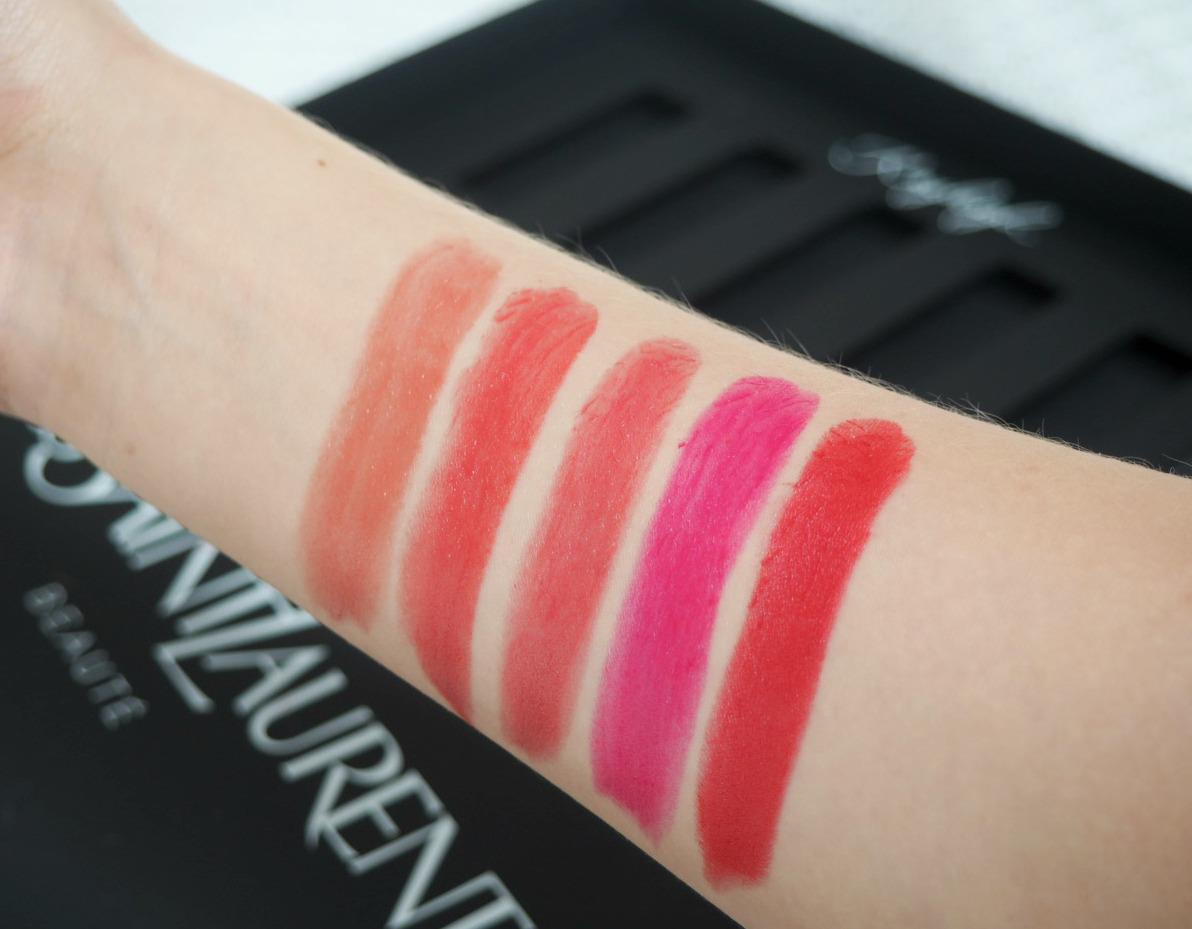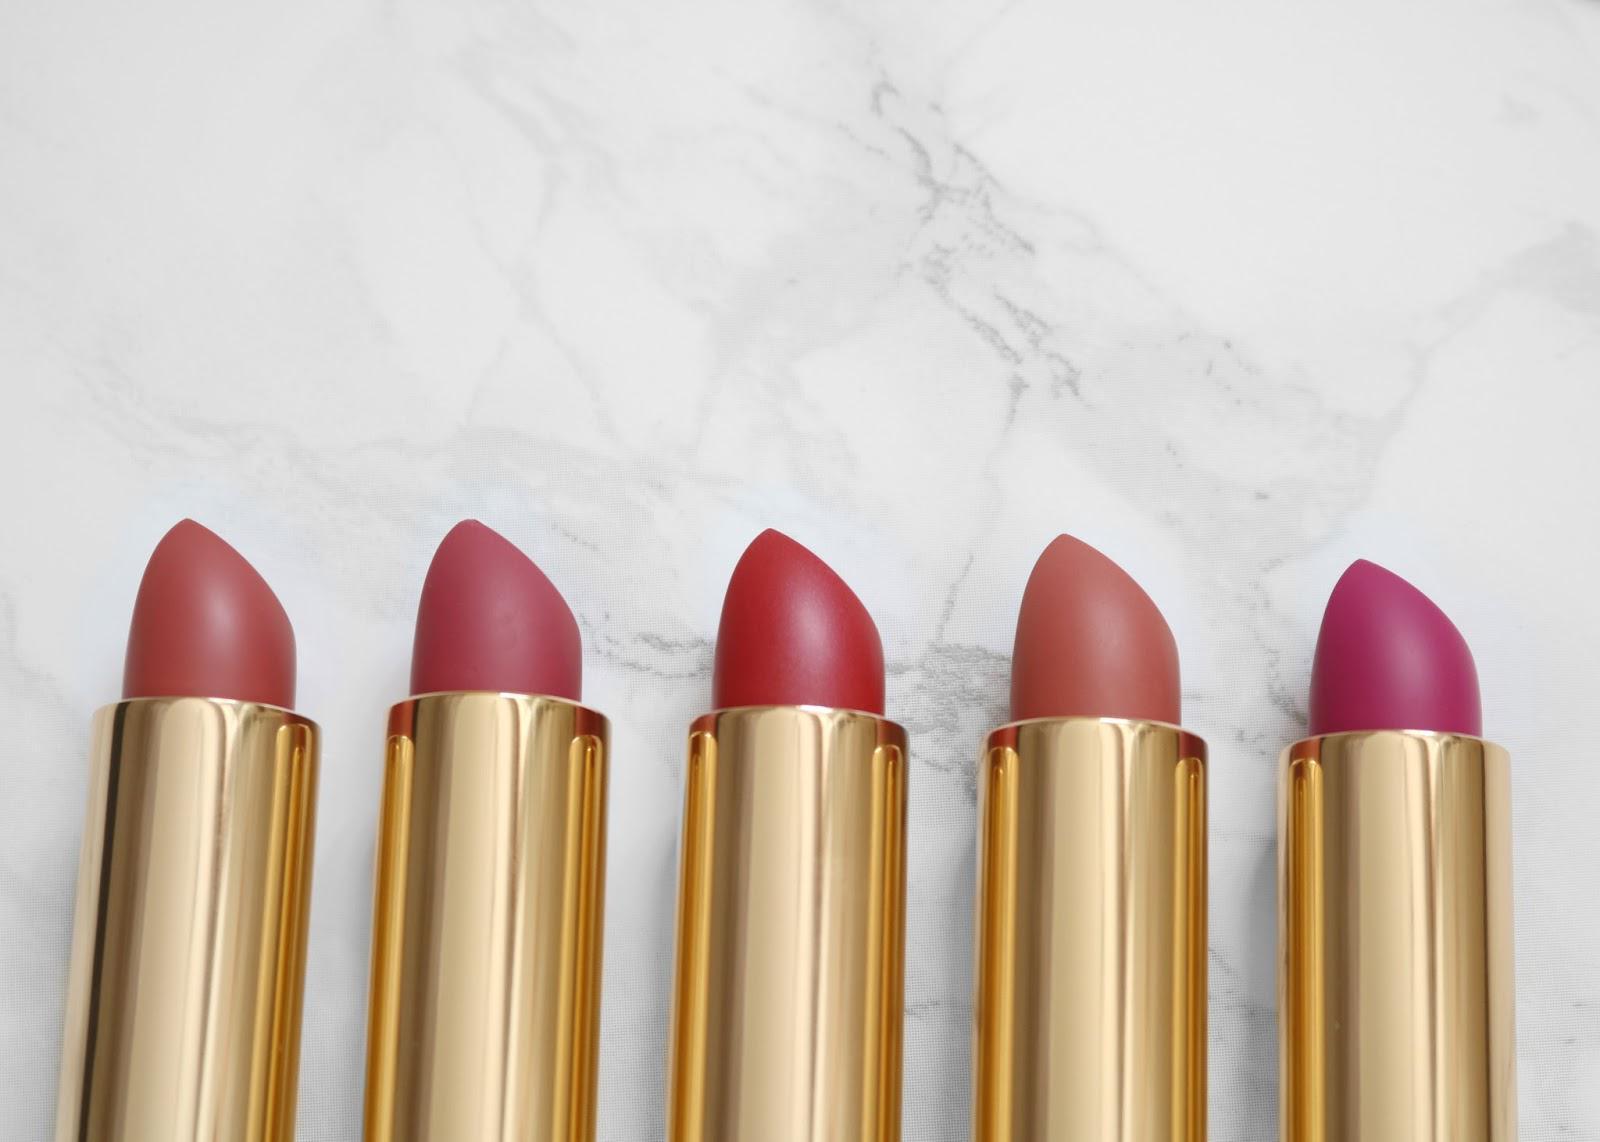The first image is the image on the left, the second image is the image on the right. Examine the images to the left and right. Is the description "The right image contains a human arm with several different shades of lipstick drawn on it." accurate? Answer yes or no. No. The first image is the image on the left, the second image is the image on the right. Evaluate the accuracy of this statement regarding the images: "One image features a row of five uncapped tube lipsticks, and the other image shows an inner arm with five lipstick marks.". Is it true? Answer yes or no. Yes. 